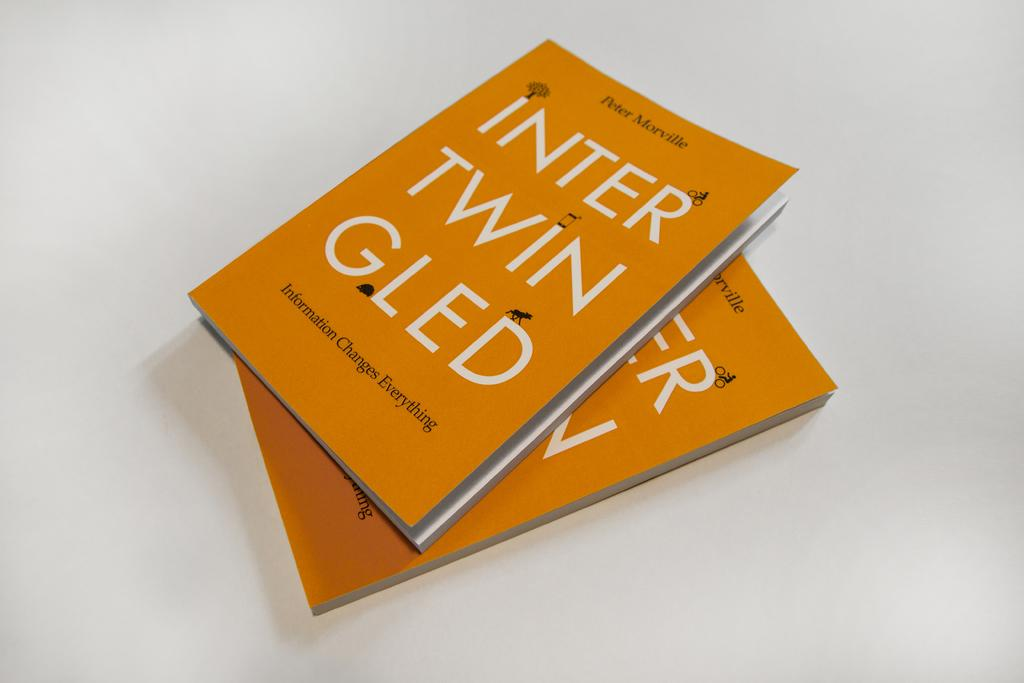<image>
Render a clear and concise summary of the photo. Two copies of the book Intertwingled by Peter Morville. 